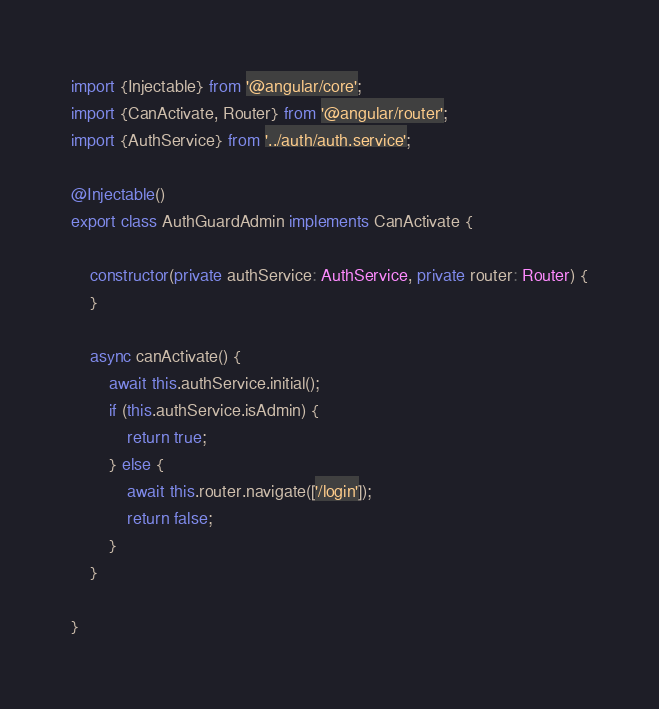<code> <loc_0><loc_0><loc_500><loc_500><_TypeScript_>import {Injectable} from '@angular/core';
import {CanActivate, Router} from '@angular/router';
import {AuthService} from '../auth/auth.service';

@Injectable()
export class AuthGuardAdmin implements CanActivate {

    constructor(private authService: AuthService, private router: Router) {
    }

    async canActivate() {
        await this.authService.initial();
        if (this.authService.isAdmin) {
            return true;
        } else {
            await this.router.navigate(['/login']);
            return false;
        }
    }

}
</code> 